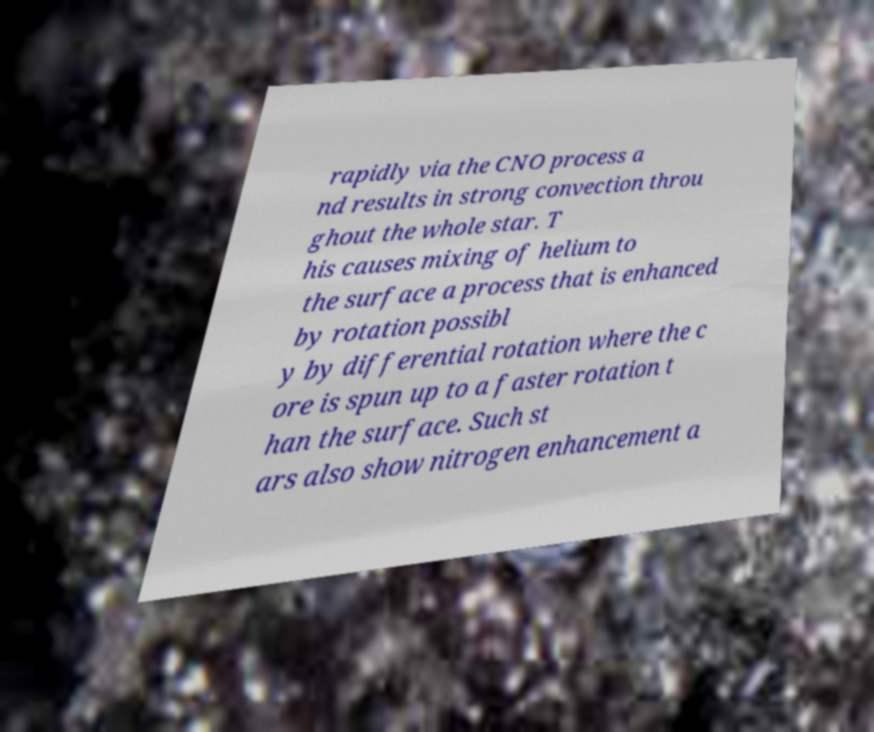Can you accurately transcribe the text from the provided image for me? rapidly via the CNO process a nd results in strong convection throu ghout the whole star. T his causes mixing of helium to the surface a process that is enhanced by rotation possibl y by differential rotation where the c ore is spun up to a faster rotation t han the surface. Such st ars also show nitrogen enhancement a 